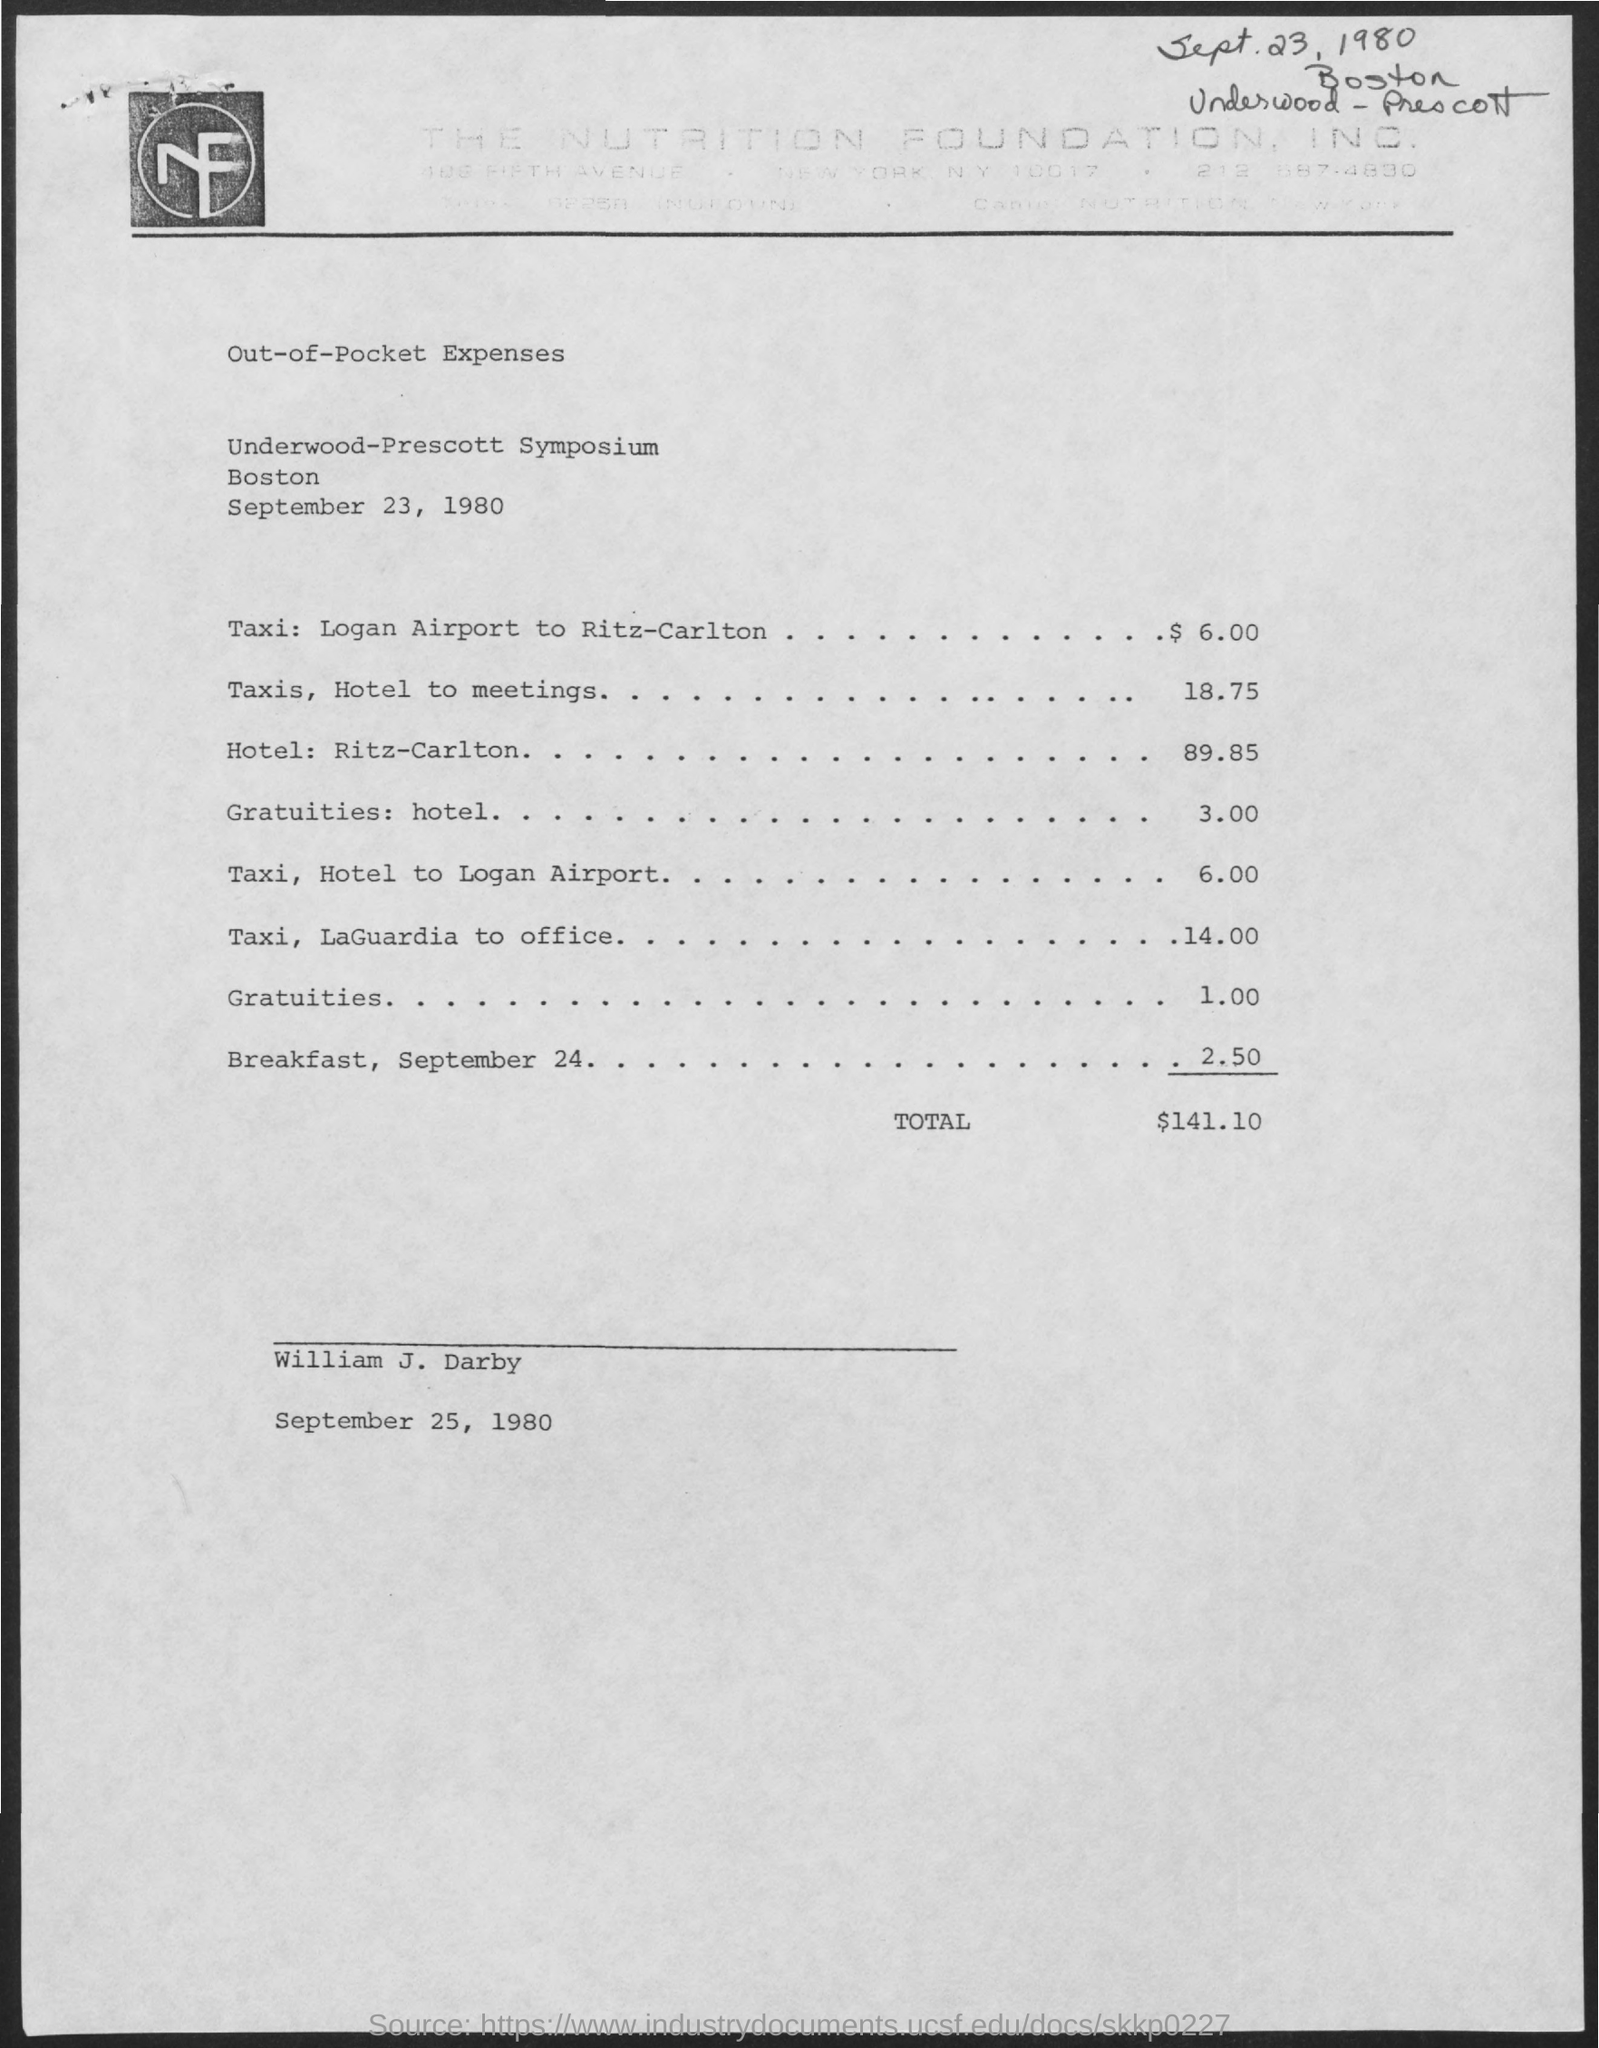What was the largest expense on this document? The largest single expense item listed is 'Hotel: Ritz-Carlton', which cost $89.85. What dates are mentioned in the document? The document lists expenses for September 23, 1980, and mentions breakfast for September 24, 1980. It was signed on September 25, 1980. 